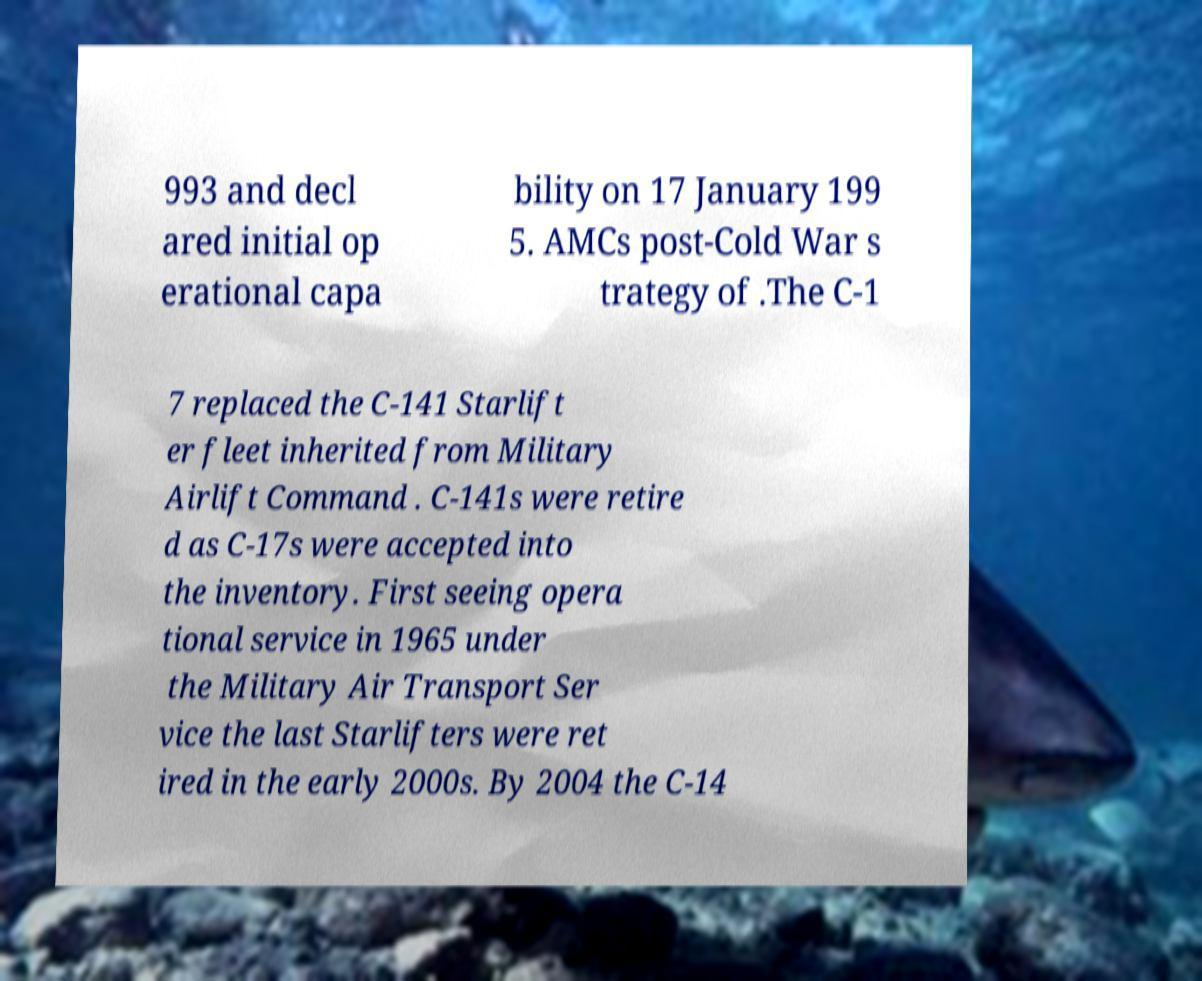Can you accurately transcribe the text from the provided image for me? 993 and decl ared initial op erational capa bility on 17 January 199 5. AMCs post-Cold War s trategy of .The C-1 7 replaced the C-141 Starlift er fleet inherited from Military Airlift Command . C-141s were retire d as C-17s were accepted into the inventory. First seeing opera tional service in 1965 under the Military Air Transport Ser vice the last Starlifters were ret ired in the early 2000s. By 2004 the C-14 